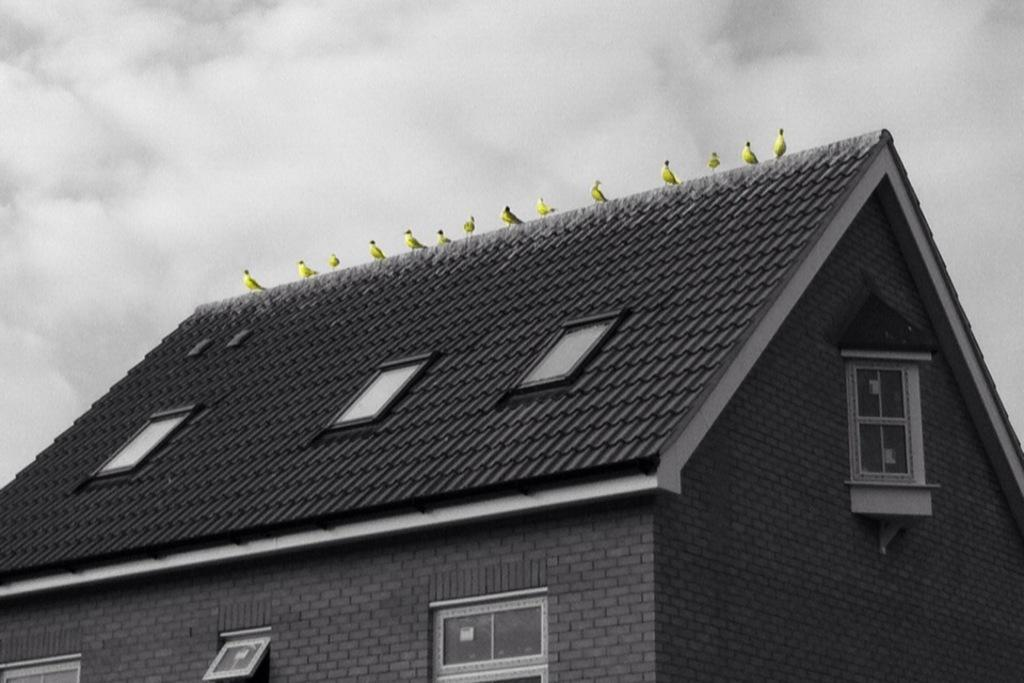What type of structure is present in the image? There is a building in the image. What can be observed about the building's roof? The building has roof tiles. Are there any decorative elements on the building? Yes, there are yellow color flowers on the building. What is visible at the top of the image? The sky is visible at the top of the image. What can be seen in the sky? There are clouds in the sky. What organization is responsible for the waste management in the image? There is no mention of waste management or any organization in the image. 